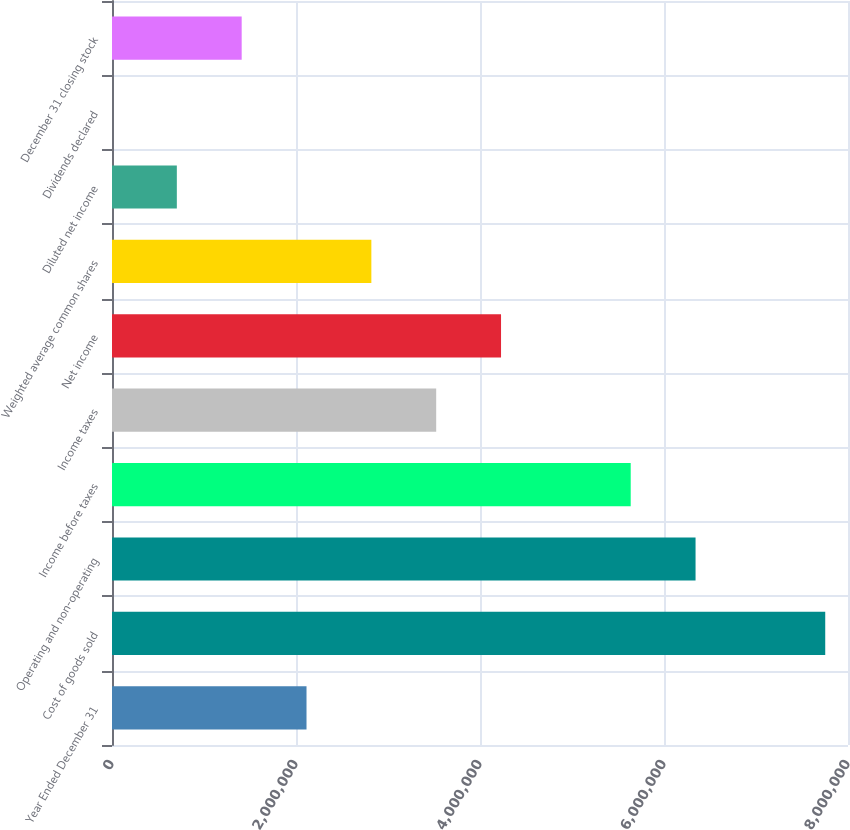Convert chart to OTSL. <chart><loc_0><loc_0><loc_500><loc_500><bar_chart><fcel>Year Ended December 31<fcel>Cost of goods sold<fcel>Operating and non-operating<fcel>Income before taxes<fcel>Income taxes<fcel>Net income<fcel>Weighted average common shares<fcel>Diluted net income<fcel>Dividends declared<fcel>December 31 closing stock<nl><fcel>2.11433e+06<fcel>7.75252e+06<fcel>6.34298e+06<fcel>5.6382e+06<fcel>3.52388e+06<fcel>4.22865e+06<fcel>2.8191e+06<fcel>704776<fcel>1.6<fcel>1.40955e+06<nl></chart> 